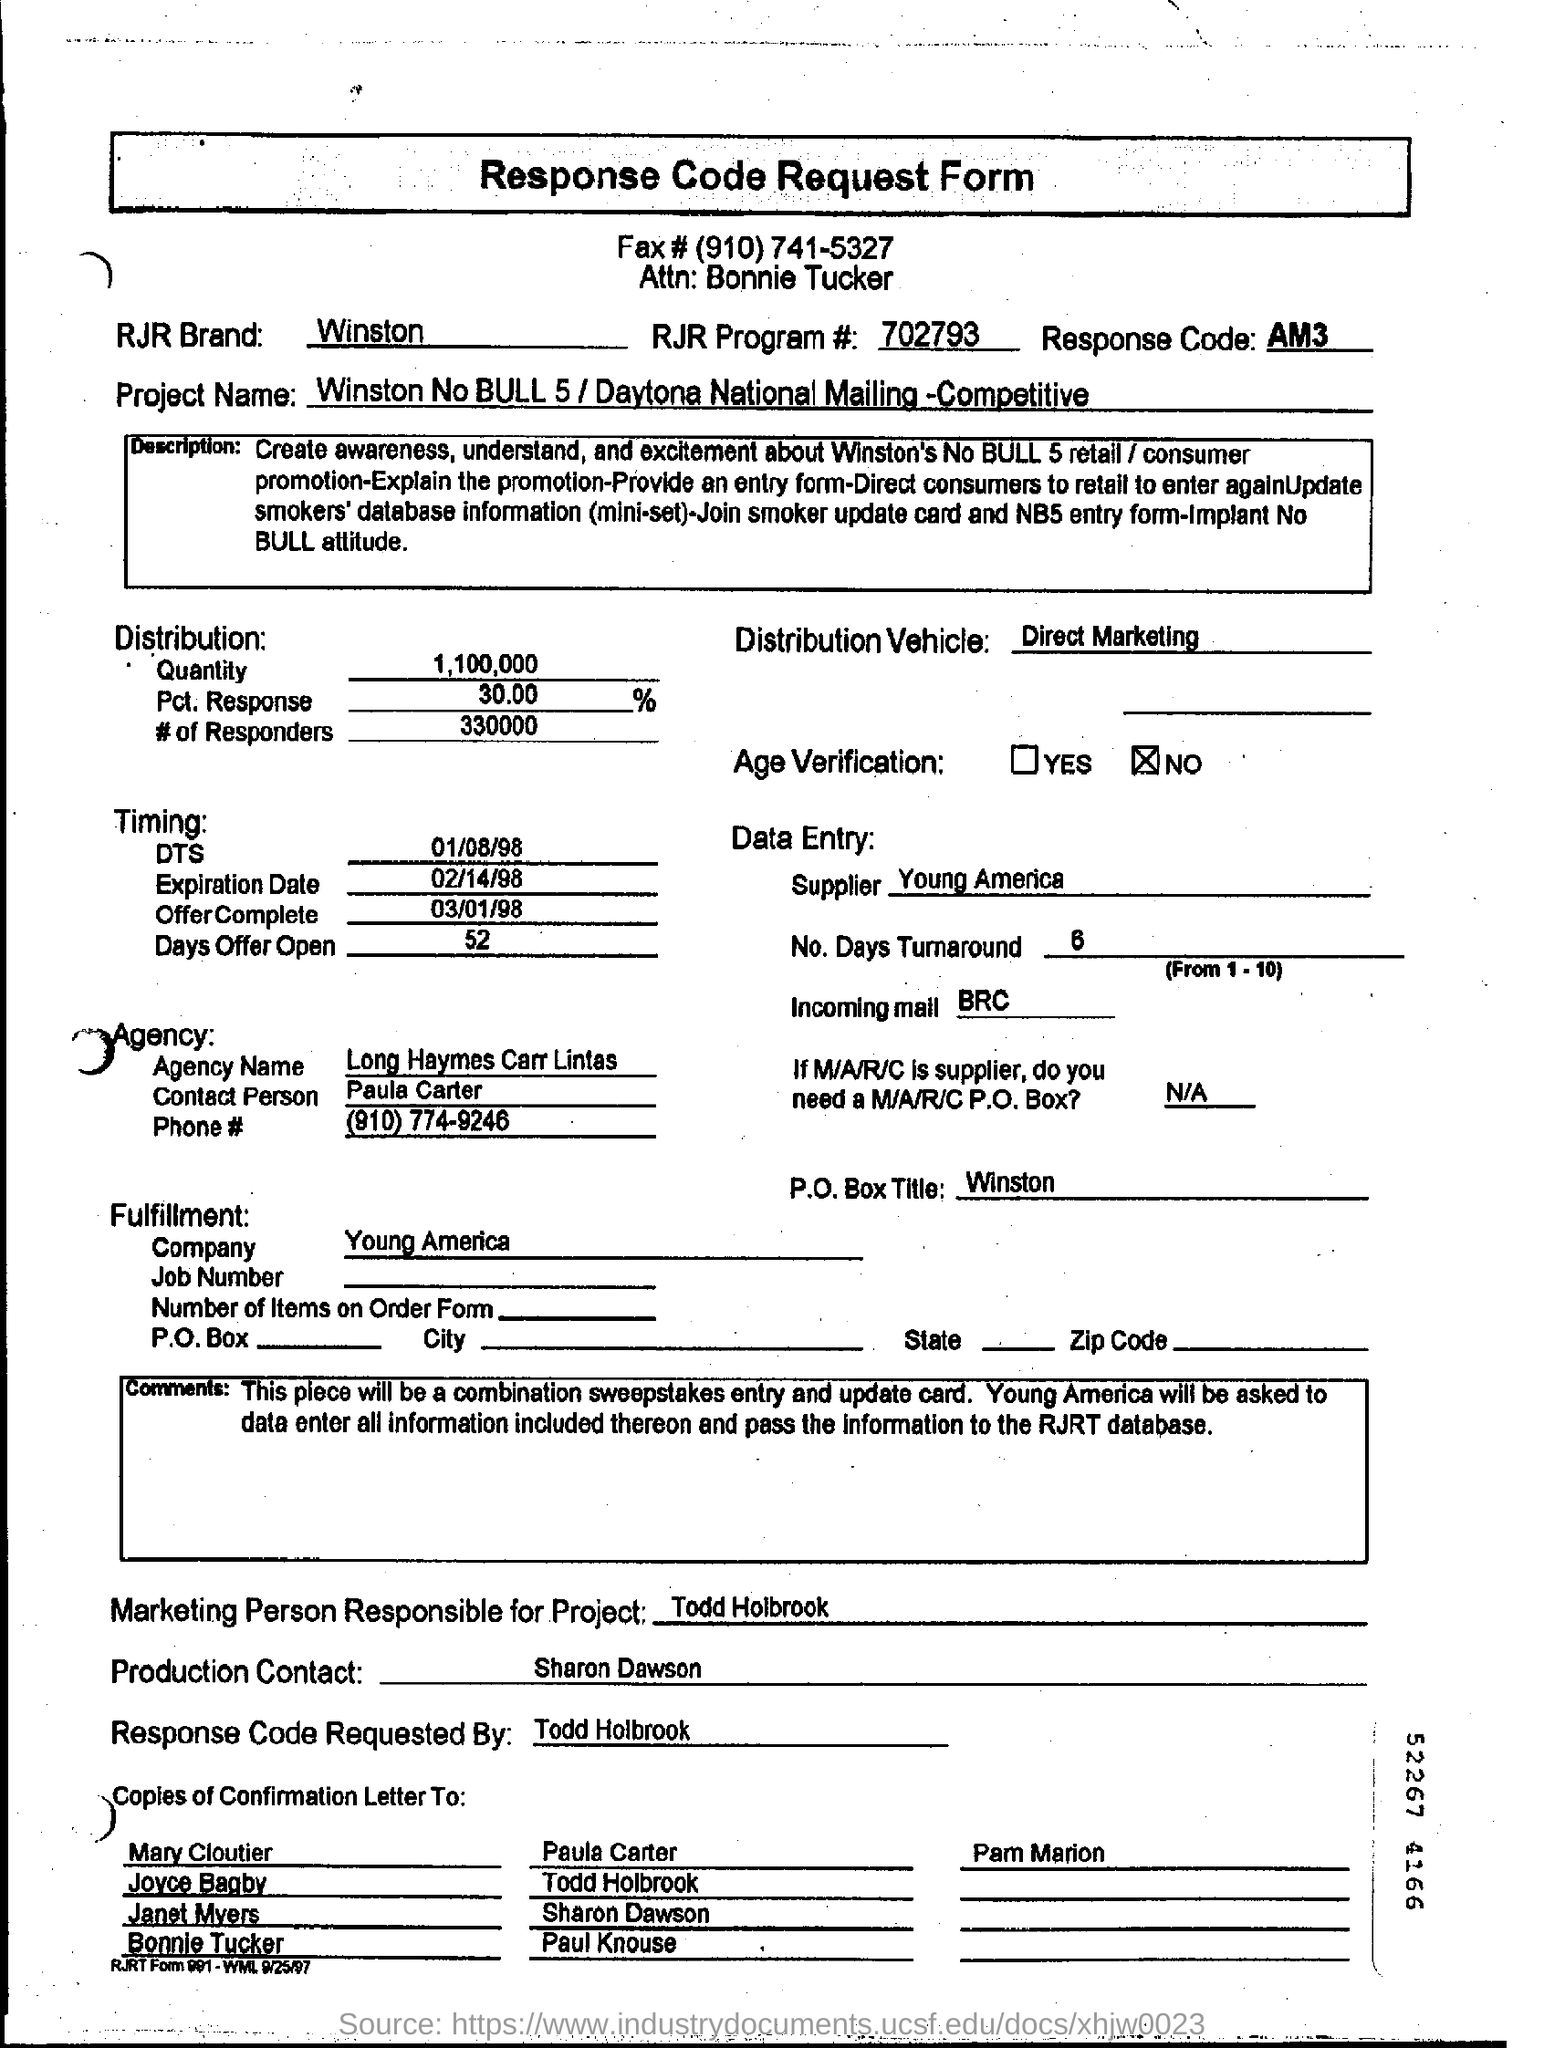Draw attention to some important aspects in this diagram. The person's name is Bonnie Tucker. The contact person for the agency is Paula Carter. The RJR brand is named Winston. We have a quantity of 1,100,000 units to be distributed. Young America is the supplier company for the data entry. 